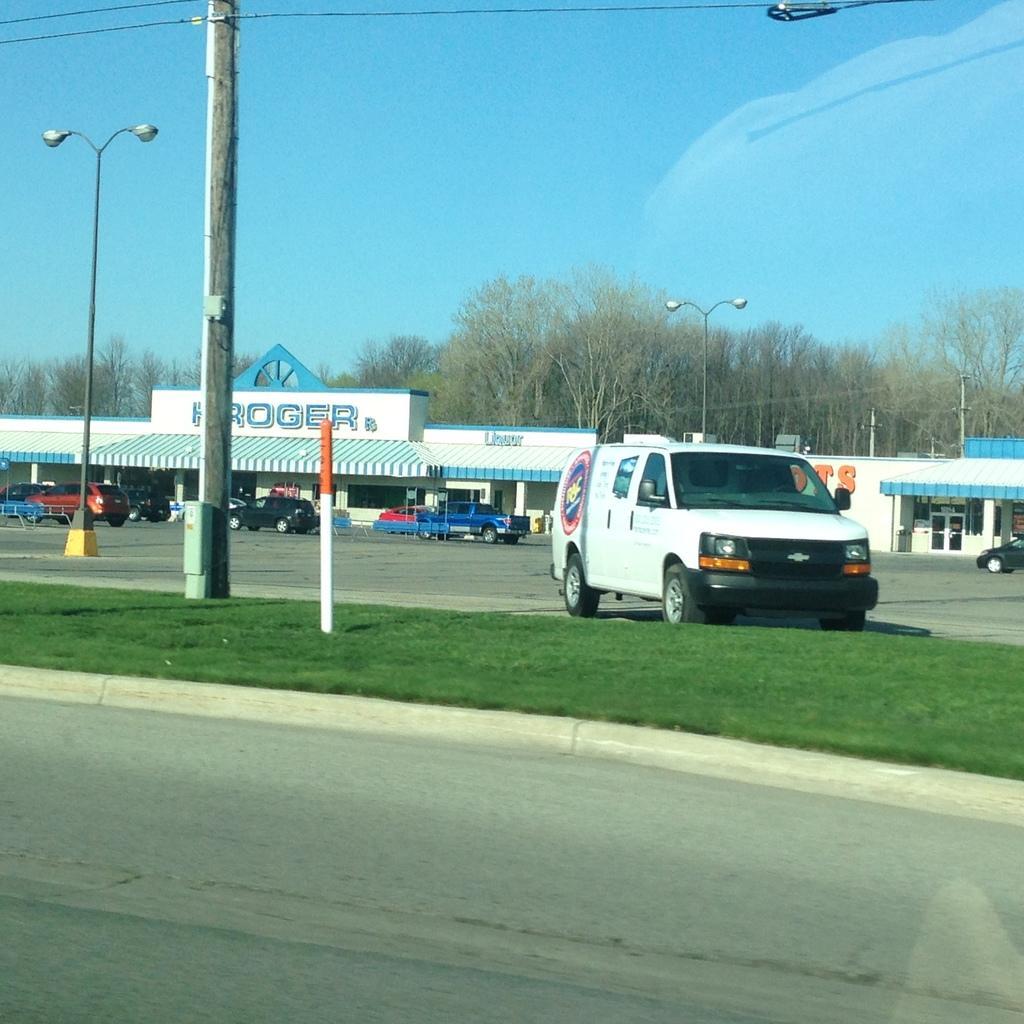Please provide a concise description of this image. In this image we can see road, there is grass and in the background of the image there are some vehicles parked near the shop, there are some street lights, poles, wires, there are some trees and clear sky. 